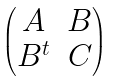Convert formula to latex. <formula><loc_0><loc_0><loc_500><loc_500>\begin{pmatrix} A & B \\ B ^ { t } & C \end{pmatrix}</formula> 